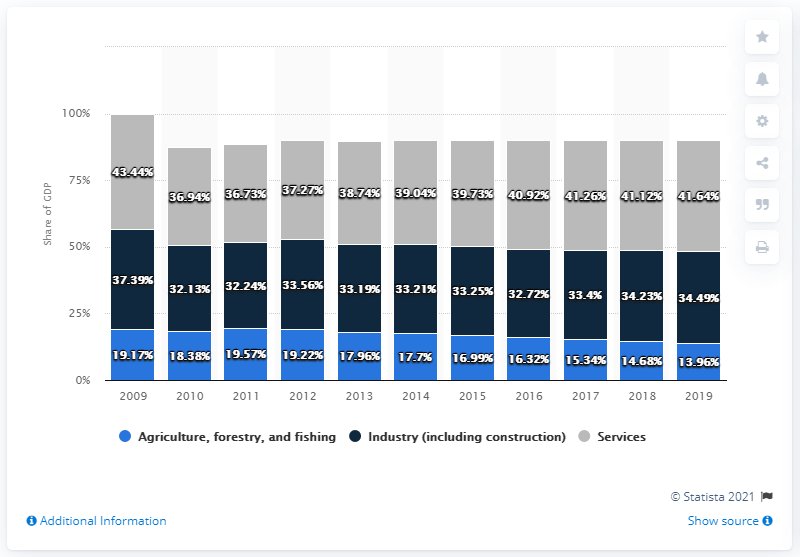Point out several critical features in this image. In 2019, Vietnam's service sector made a significant contribution to the country's Gross Domestic Product, accounting for 41.64% of the total GDP. The result of adding the tallest grey bar and the shortest light blue bar is 57.5. The summation of the biggest share of GDP by Services and the smallest share of GDP by Industry (including construction) from 2009 to 2019 was 75.57. 